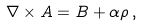<formula> <loc_0><loc_0><loc_500><loc_500>\nabla \times A = B + \alpha \rho \, ,</formula> 